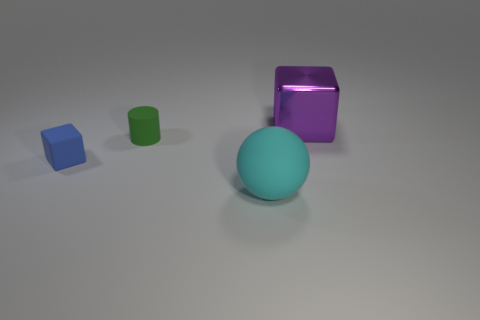Add 2 metallic blocks. How many objects exist? 6 Subtract all balls. How many objects are left? 3 Add 3 small blue blocks. How many small blue blocks are left? 4 Add 3 green matte cylinders. How many green matte cylinders exist? 4 Subtract 0 blue spheres. How many objects are left? 4 Subtract all tiny green rubber things. Subtract all small blue cubes. How many objects are left? 2 